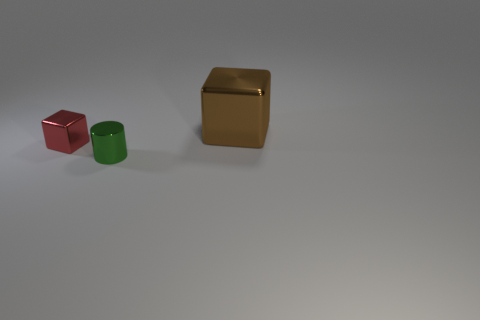What number of green metallic things are the same size as the green cylinder?
Offer a very short reply. 0. There is a shiny block in front of the big brown cube; are there any tiny cylinders that are left of it?
Your answer should be very brief. No. What number of things are large brown metallic objects or small metal objects?
Provide a succinct answer. 3. The big object behind the metal thing that is in front of the shiny cube left of the large shiny thing is what color?
Your answer should be compact. Brown. Do the red block and the green shiny cylinder have the same size?
Provide a short and direct response. Yes. What number of things are either shiny blocks on the left side of the brown metal thing or small green cylinders that are in front of the big metallic cube?
Ensure brevity in your answer.  2. How many other objects are the same material as the cylinder?
Your response must be concise. 2. Is the shape of the brown thing the same as the red metallic thing?
Offer a very short reply. Yes. How big is the metal thing on the right side of the small green metallic object?
Your answer should be very brief. Large. Do the green metallic cylinder and the cube behind the red shiny block have the same size?
Ensure brevity in your answer.  No. 